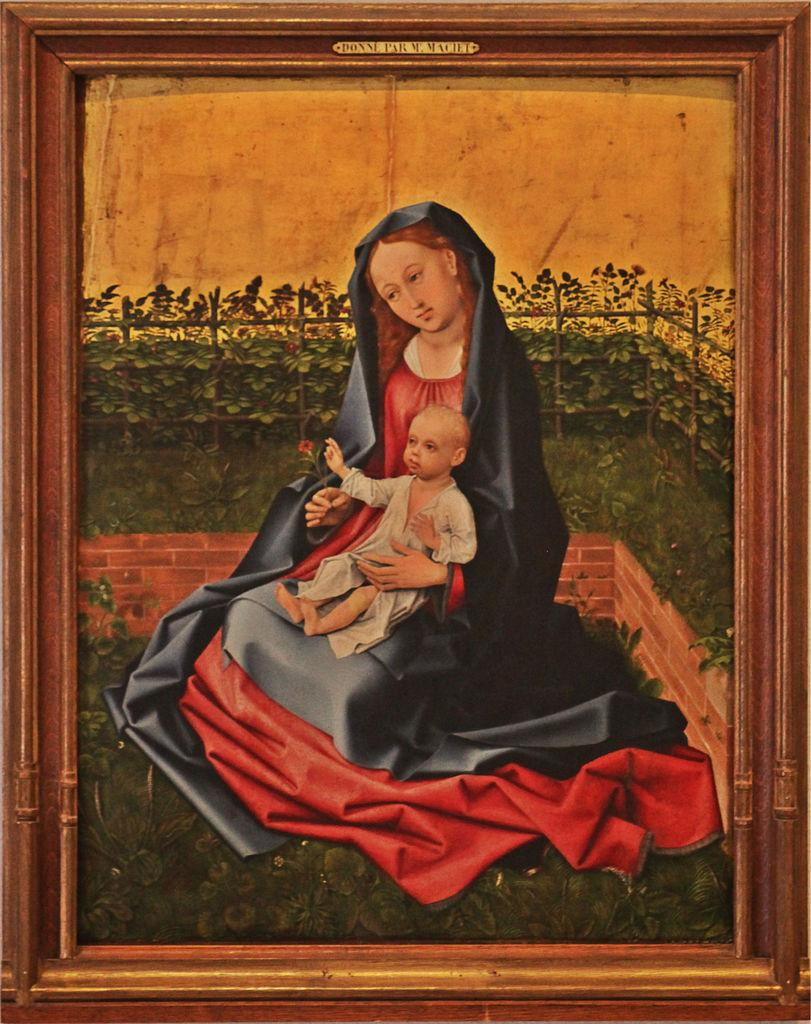Provide a one-sentence caption for the provided image. framed painting labeled DONNE PARM MACIET of woman holding a child. 